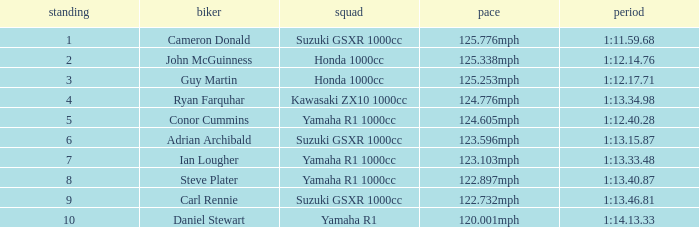What time did team kawasaki zx10 1000cc have? 1:13.34.98. 